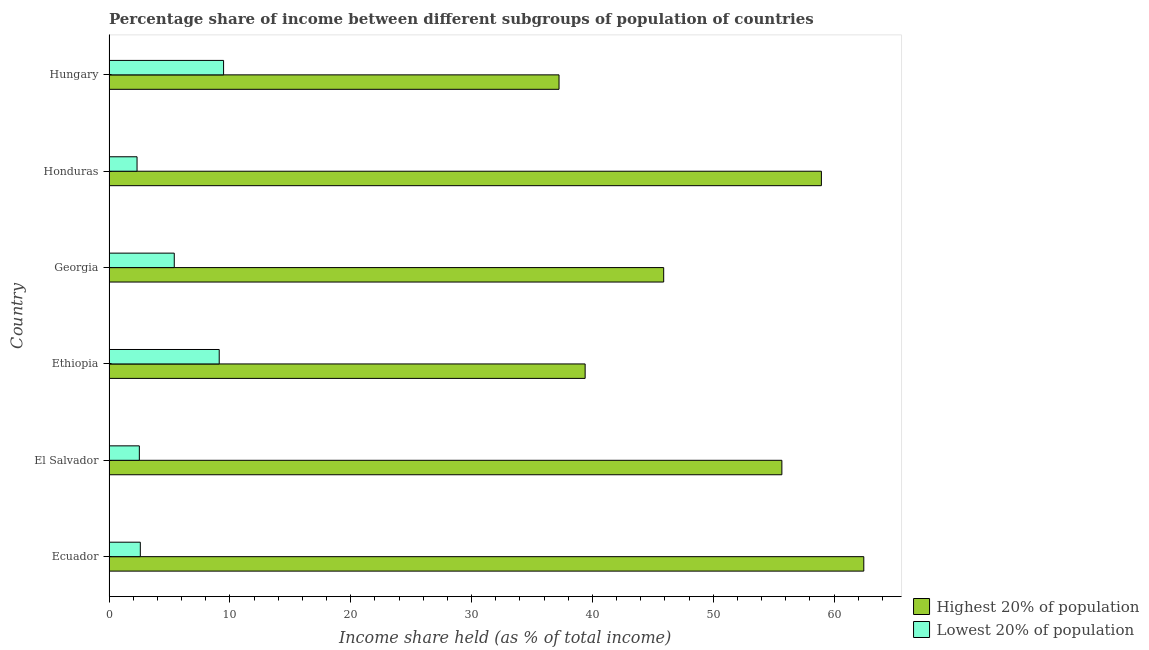Are the number of bars on each tick of the Y-axis equal?
Keep it short and to the point. Yes. What is the label of the 5th group of bars from the top?
Give a very brief answer. El Salvador. In how many cases, is the number of bars for a given country not equal to the number of legend labels?
Keep it short and to the point. 0. What is the income share held by highest 20% of the population in Honduras?
Offer a very short reply. 58.95. Across all countries, what is the maximum income share held by highest 20% of the population?
Your answer should be very brief. 62.46. Across all countries, what is the minimum income share held by highest 20% of the population?
Your answer should be very brief. 37.24. In which country was the income share held by lowest 20% of the population maximum?
Provide a short and direct response. Hungary. In which country was the income share held by highest 20% of the population minimum?
Your answer should be compact. Hungary. What is the total income share held by lowest 20% of the population in the graph?
Offer a terse response. 31.42. What is the difference between the income share held by lowest 20% of the population in Ethiopia and that in Georgia?
Your response must be concise. 3.72. What is the difference between the income share held by lowest 20% of the population in Hungary and the income share held by highest 20% of the population in El Salvador?
Your answer should be compact. -46.2. What is the average income share held by lowest 20% of the population per country?
Ensure brevity in your answer.  5.24. What is the difference between the income share held by lowest 20% of the population and income share held by highest 20% of the population in Ecuador?
Provide a succinct answer. -59.87. What is the ratio of the income share held by highest 20% of the population in Ethiopia to that in Hungary?
Keep it short and to the point. 1.06. Is the income share held by highest 20% of the population in Ecuador less than that in Georgia?
Provide a succinct answer. No. Is the difference between the income share held by lowest 20% of the population in Ethiopia and Georgia greater than the difference between the income share held by highest 20% of the population in Ethiopia and Georgia?
Ensure brevity in your answer.  Yes. What is the difference between the highest and the second highest income share held by highest 20% of the population?
Ensure brevity in your answer.  3.51. What is the difference between the highest and the lowest income share held by highest 20% of the population?
Offer a terse response. 25.22. What does the 2nd bar from the top in Honduras represents?
Your response must be concise. Highest 20% of population. What does the 1st bar from the bottom in Hungary represents?
Provide a short and direct response. Highest 20% of population. Are all the bars in the graph horizontal?
Your answer should be very brief. Yes. What is the difference between two consecutive major ticks on the X-axis?
Provide a succinct answer. 10. Does the graph contain any zero values?
Your answer should be very brief. No. Where does the legend appear in the graph?
Your answer should be compact. Bottom right. How many legend labels are there?
Provide a short and direct response. 2. How are the legend labels stacked?
Give a very brief answer. Vertical. What is the title of the graph?
Your response must be concise. Percentage share of income between different subgroups of population of countries. What is the label or title of the X-axis?
Your answer should be very brief. Income share held (as % of total income). What is the label or title of the Y-axis?
Provide a short and direct response. Country. What is the Income share held (as % of total income) in Highest 20% of population in Ecuador?
Ensure brevity in your answer.  62.46. What is the Income share held (as % of total income) of Lowest 20% of population in Ecuador?
Your response must be concise. 2.59. What is the Income share held (as % of total income) of Highest 20% of population in El Salvador?
Provide a succinct answer. 55.68. What is the Income share held (as % of total income) in Lowest 20% of population in El Salvador?
Make the answer very short. 2.51. What is the Income share held (as % of total income) of Highest 20% of population in Ethiopia?
Keep it short and to the point. 39.4. What is the Income share held (as % of total income) of Lowest 20% of population in Ethiopia?
Your answer should be compact. 9.12. What is the Income share held (as % of total income) in Highest 20% of population in Georgia?
Your answer should be compact. 45.9. What is the Income share held (as % of total income) in Lowest 20% of population in Georgia?
Give a very brief answer. 5.4. What is the Income share held (as % of total income) in Highest 20% of population in Honduras?
Keep it short and to the point. 58.95. What is the Income share held (as % of total income) of Lowest 20% of population in Honduras?
Give a very brief answer. 2.32. What is the Income share held (as % of total income) in Highest 20% of population in Hungary?
Offer a very short reply. 37.24. What is the Income share held (as % of total income) of Lowest 20% of population in Hungary?
Provide a succinct answer. 9.48. Across all countries, what is the maximum Income share held (as % of total income) in Highest 20% of population?
Offer a very short reply. 62.46. Across all countries, what is the maximum Income share held (as % of total income) in Lowest 20% of population?
Your response must be concise. 9.48. Across all countries, what is the minimum Income share held (as % of total income) in Highest 20% of population?
Make the answer very short. 37.24. Across all countries, what is the minimum Income share held (as % of total income) of Lowest 20% of population?
Make the answer very short. 2.32. What is the total Income share held (as % of total income) in Highest 20% of population in the graph?
Offer a terse response. 299.63. What is the total Income share held (as % of total income) of Lowest 20% of population in the graph?
Offer a terse response. 31.42. What is the difference between the Income share held (as % of total income) of Highest 20% of population in Ecuador and that in El Salvador?
Offer a very short reply. 6.78. What is the difference between the Income share held (as % of total income) of Lowest 20% of population in Ecuador and that in El Salvador?
Your answer should be compact. 0.08. What is the difference between the Income share held (as % of total income) of Highest 20% of population in Ecuador and that in Ethiopia?
Provide a short and direct response. 23.06. What is the difference between the Income share held (as % of total income) of Lowest 20% of population in Ecuador and that in Ethiopia?
Provide a succinct answer. -6.53. What is the difference between the Income share held (as % of total income) of Highest 20% of population in Ecuador and that in Georgia?
Ensure brevity in your answer.  16.56. What is the difference between the Income share held (as % of total income) of Lowest 20% of population in Ecuador and that in Georgia?
Provide a short and direct response. -2.81. What is the difference between the Income share held (as % of total income) of Highest 20% of population in Ecuador and that in Honduras?
Keep it short and to the point. 3.51. What is the difference between the Income share held (as % of total income) of Lowest 20% of population in Ecuador and that in Honduras?
Give a very brief answer. 0.27. What is the difference between the Income share held (as % of total income) in Highest 20% of population in Ecuador and that in Hungary?
Keep it short and to the point. 25.22. What is the difference between the Income share held (as % of total income) of Lowest 20% of population in Ecuador and that in Hungary?
Make the answer very short. -6.89. What is the difference between the Income share held (as % of total income) of Highest 20% of population in El Salvador and that in Ethiopia?
Your response must be concise. 16.28. What is the difference between the Income share held (as % of total income) of Lowest 20% of population in El Salvador and that in Ethiopia?
Provide a succinct answer. -6.61. What is the difference between the Income share held (as % of total income) of Highest 20% of population in El Salvador and that in Georgia?
Keep it short and to the point. 9.78. What is the difference between the Income share held (as % of total income) in Lowest 20% of population in El Salvador and that in Georgia?
Ensure brevity in your answer.  -2.89. What is the difference between the Income share held (as % of total income) of Highest 20% of population in El Salvador and that in Honduras?
Offer a terse response. -3.27. What is the difference between the Income share held (as % of total income) of Lowest 20% of population in El Salvador and that in Honduras?
Your answer should be very brief. 0.19. What is the difference between the Income share held (as % of total income) of Highest 20% of population in El Salvador and that in Hungary?
Keep it short and to the point. 18.44. What is the difference between the Income share held (as % of total income) in Lowest 20% of population in El Salvador and that in Hungary?
Your answer should be very brief. -6.97. What is the difference between the Income share held (as % of total income) in Highest 20% of population in Ethiopia and that in Georgia?
Provide a short and direct response. -6.5. What is the difference between the Income share held (as % of total income) of Lowest 20% of population in Ethiopia and that in Georgia?
Provide a short and direct response. 3.72. What is the difference between the Income share held (as % of total income) of Highest 20% of population in Ethiopia and that in Honduras?
Offer a very short reply. -19.55. What is the difference between the Income share held (as % of total income) of Lowest 20% of population in Ethiopia and that in Honduras?
Give a very brief answer. 6.8. What is the difference between the Income share held (as % of total income) in Highest 20% of population in Ethiopia and that in Hungary?
Make the answer very short. 2.16. What is the difference between the Income share held (as % of total income) in Lowest 20% of population in Ethiopia and that in Hungary?
Provide a succinct answer. -0.36. What is the difference between the Income share held (as % of total income) in Highest 20% of population in Georgia and that in Honduras?
Give a very brief answer. -13.05. What is the difference between the Income share held (as % of total income) of Lowest 20% of population in Georgia and that in Honduras?
Your response must be concise. 3.08. What is the difference between the Income share held (as % of total income) of Highest 20% of population in Georgia and that in Hungary?
Offer a terse response. 8.66. What is the difference between the Income share held (as % of total income) of Lowest 20% of population in Georgia and that in Hungary?
Your response must be concise. -4.08. What is the difference between the Income share held (as % of total income) in Highest 20% of population in Honduras and that in Hungary?
Your answer should be compact. 21.71. What is the difference between the Income share held (as % of total income) of Lowest 20% of population in Honduras and that in Hungary?
Give a very brief answer. -7.16. What is the difference between the Income share held (as % of total income) in Highest 20% of population in Ecuador and the Income share held (as % of total income) in Lowest 20% of population in El Salvador?
Ensure brevity in your answer.  59.95. What is the difference between the Income share held (as % of total income) in Highest 20% of population in Ecuador and the Income share held (as % of total income) in Lowest 20% of population in Ethiopia?
Offer a terse response. 53.34. What is the difference between the Income share held (as % of total income) of Highest 20% of population in Ecuador and the Income share held (as % of total income) of Lowest 20% of population in Georgia?
Offer a terse response. 57.06. What is the difference between the Income share held (as % of total income) of Highest 20% of population in Ecuador and the Income share held (as % of total income) of Lowest 20% of population in Honduras?
Give a very brief answer. 60.14. What is the difference between the Income share held (as % of total income) in Highest 20% of population in Ecuador and the Income share held (as % of total income) in Lowest 20% of population in Hungary?
Offer a very short reply. 52.98. What is the difference between the Income share held (as % of total income) in Highest 20% of population in El Salvador and the Income share held (as % of total income) in Lowest 20% of population in Ethiopia?
Give a very brief answer. 46.56. What is the difference between the Income share held (as % of total income) of Highest 20% of population in El Salvador and the Income share held (as % of total income) of Lowest 20% of population in Georgia?
Keep it short and to the point. 50.28. What is the difference between the Income share held (as % of total income) in Highest 20% of population in El Salvador and the Income share held (as % of total income) in Lowest 20% of population in Honduras?
Ensure brevity in your answer.  53.36. What is the difference between the Income share held (as % of total income) in Highest 20% of population in El Salvador and the Income share held (as % of total income) in Lowest 20% of population in Hungary?
Provide a short and direct response. 46.2. What is the difference between the Income share held (as % of total income) of Highest 20% of population in Ethiopia and the Income share held (as % of total income) of Lowest 20% of population in Georgia?
Keep it short and to the point. 34. What is the difference between the Income share held (as % of total income) in Highest 20% of population in Ethiopia and the Income share held (as % of total income) in Lowest 20% of population in Honduras?
Your answer should be compact. 37.08. What is the difference between the Income share held (as % of total income) in Highest 20% of population in Ethiopia and the Income share held (as % of total income) in Lowest 20% of population in Hungary?
Your answer should be very brief. 29.92. What is the difference between the Income share held (as % of total income) of Highest 20% of population in Georgia and the Income share held (as % of total income) of Lowest 20% of population in Honduras?
Offer a terse response. 43.58. What is the difference between the Income share held (as % of total income) in Highest 20% of population in Georgia and the Income share held (as % of total income) in Lowest 20% of population in Hungary?
Offer a very short reply. 36.42. What is the difference between the Income share held (as % of total income) of Highest 20% of population in Honduras and the Income share held (as % of total income) of Lowest 20% of population in Hungary?
Keep it short and to the point. 49.47. What is the average Income share held (as % of total income) in Highest 20% of population per country?
Your answer should be very brief. 49.94. What is the average Income share held (as % of total income) of Lowest 20% of population per country?
Ensure brevity in your answer.  5.24. What is the difference between the Income share held (as % of total income) in Highest 20% of population and Income share held (as % of total income) in Lowest 20% of population in Ecuador?
Keep it short and to the point. 59.87. What is the difference between the Income share held (as % of total income) of Highest 20% of population and Income share held (as % of total income) of Lowest 20% of population in El Salvador?
Your response must be concise. 53.17. What is the difference between the Income share held (as % of total income) in Highest 20% of population and Income share held (as % of total income) in Lowest 20% of population in Ethiopia?
Your answer should be very brief. 30.28. What is the difference between the Income share held (as % of total income) of Highest 20% of population and Income share held (as % of total income) of Lowest 20% of population in Georgia?
Keep it short and to the point. 40.5. What is the difference between the Income share held (as % of total income) in Highest 20% of population and Income share held (as % of total income) in Lowest 20% of population in Honduras?
Offer a very short reply. 56.63. What is the difference between the Income share held (as % of total income) in Highest 20% of population and Income share held (as % of total income) in Lowest 20% of population in Hungary?
Your answer should be compact. 27.76. What is the ratio of the Income share held (as % of total income) of Highest 20% of population in Ecuador to that in El Salvador?
Provide a succinct answer. 1.12. What is the ratio of the Income share held (as % of total income) of Lowest 20% of population in Ecuador to that in El Salvador?
Offer a very short reply. 1.03. What is the ratio of the Income share held (as % of total income) of Highest 20% of population in Ecuador to that in Ethiopia?
Give a very brief answer. 1.59. What is the ratio of the Income share held (as % of total income) in Lowest 20% of population in Ecuador to that in Ethiopia?
Provide a short and direct response. 0.28. What is the ratio of the Income share held (as % of total income) of Highest 20% of population in Ecuador to that in Georgia?
Your answer should be very brief. 1.36. What is the ratio of the Income share held (as % of total income) in Lowest 20% of population in Ecuador to that in Georgia?
Offer a terse response. 0.48. What is the ratio of the Income share held (as % of total income) in Highest 20% of population in Ecuador to that in Honduras?
Provide a short and direct response. 1.06. What is the ratio of the Income share held (as % of total income) in Lowest 20% of population in Ecuador to that in Honduras?
Your answer should be compact. 1.12. What is the ratio of the Income share held (as % of total income) in Highest 20% of population in Ecuador to that in Hungary?
Offer a terse response. 1.68. What is the ratio of the Income share held (as % of total income) in Lowest 20% of population in Ecuador to that in Hungary?
Offer a terse response. 0.27. What is the ratio of the Income share held (as % of total income) in Highest 20% of population in El Salvador to that in Ethiopia?
Keep it short and to the point. 1.41. What is the ratio of the Income share held (as % of total income) in Lowest 20% of population in El Salvador to that in Ethiopia?
Offer a terse response. 0.28. What is the ratio of the Income share held (as % of total income) of Highest 20% of population in El Salvador to that in Georgia?
Your response must be concise. 1.21. What is the ratio of the Income share held (as % of total income) in Lowest 20% of population in El Salvador to that in Georgia?
Your response must be concise. 0.46. What is the ratio of the Income share held (as % of total income) in Highest 20% of population in El Salvador to that in Honduras?
Provide a succinct answer. 0.94. What is the ratio of the Income share held (as % of total income) of Lowest 20% of population in El Salvador to that in Honduras?
Offer a terse response. 1.08. What is the ratio of the Income share held (as % of total income) of Highest 20% of population in El Salvador to that in Hungary?
Give a very brief answer. 1.5. What is the ratio of the Income share held (as % of total income) of Lowest 20% of population in El Salvador to that in Hungary?
Ensure brevity in your answer.  0.26. What is the ratio of the Income share held (as % of total income) of Highest 20% of population in Ethiopia to that in Georgia?
Offer a terse response. 0.86. What is the ratio of the Income share held (as % of total income) of Lowest 20% of population in Ethiopia to that in Georgia?
Offer a terse response. 1.69. What is the ratio of the Income share held (as % of total income) of Highest 20% of population in Ethiopia to that in Honduras?
Offer a terse response. 0.67. What is the ratio of the Income share held (as % of total income) of Lowest 20% of population in Ethiopia to that in Honduras?
Make the answer very short. 3.93. What is the ratio of the Income share held (as % of total income) of Highest 20% of population in Ethiopia to that in Hungary?
Give a very brief answer. 1.06. What is the ratio of the Income share held (as % of total income) in Highest 20% of population in Georgia to that in Honduras?
Your answer should be compact. 0.78. What is the ratio of the Income share held (as % of total income) in Lowest 20% of population in Georgia to that in Honduras?
Give a very brief answer. 2.33. What is the ratio of the Income share held (as % of total income) in Highest 20% of population in Georgia to that in Hungary?
Your response must be concise. 1.23. What is the ratio of the Income share held (as % of total income) in Lowest 20% of population in Georgia to that in Hungary?
Provide a short and direct response. 0.57. What is the ratio of the Income share held (as % of total income) of Highest 20% of population in Honduras to that in Hungary?
Your answer should be very brief. 1.58. What is the ratio of the Income share held (as % of total income) of Lowest 20% of population in Honduras to that in Hungary?
Offer a terse response. 0.24. What is the difference between the highest and the second highest Income share held (as % of total income) in Highest 20% of population?
Provide a succinct answer. 3.51. What is the difference between the highest and the second highest Income share held (as % of total income) of Lowest 20% of population?
Ensure brevity in your answer.  0.36. What is the difference between the highest and the lowest Income share held (as % of total income) in Highest 20% of population?
Offer a very short reply. 25.22. What is the difference between the highest and the lowest Income share held (as % of total income) in Lowest 20% of population?
Offer a very short reply. 7.16. 